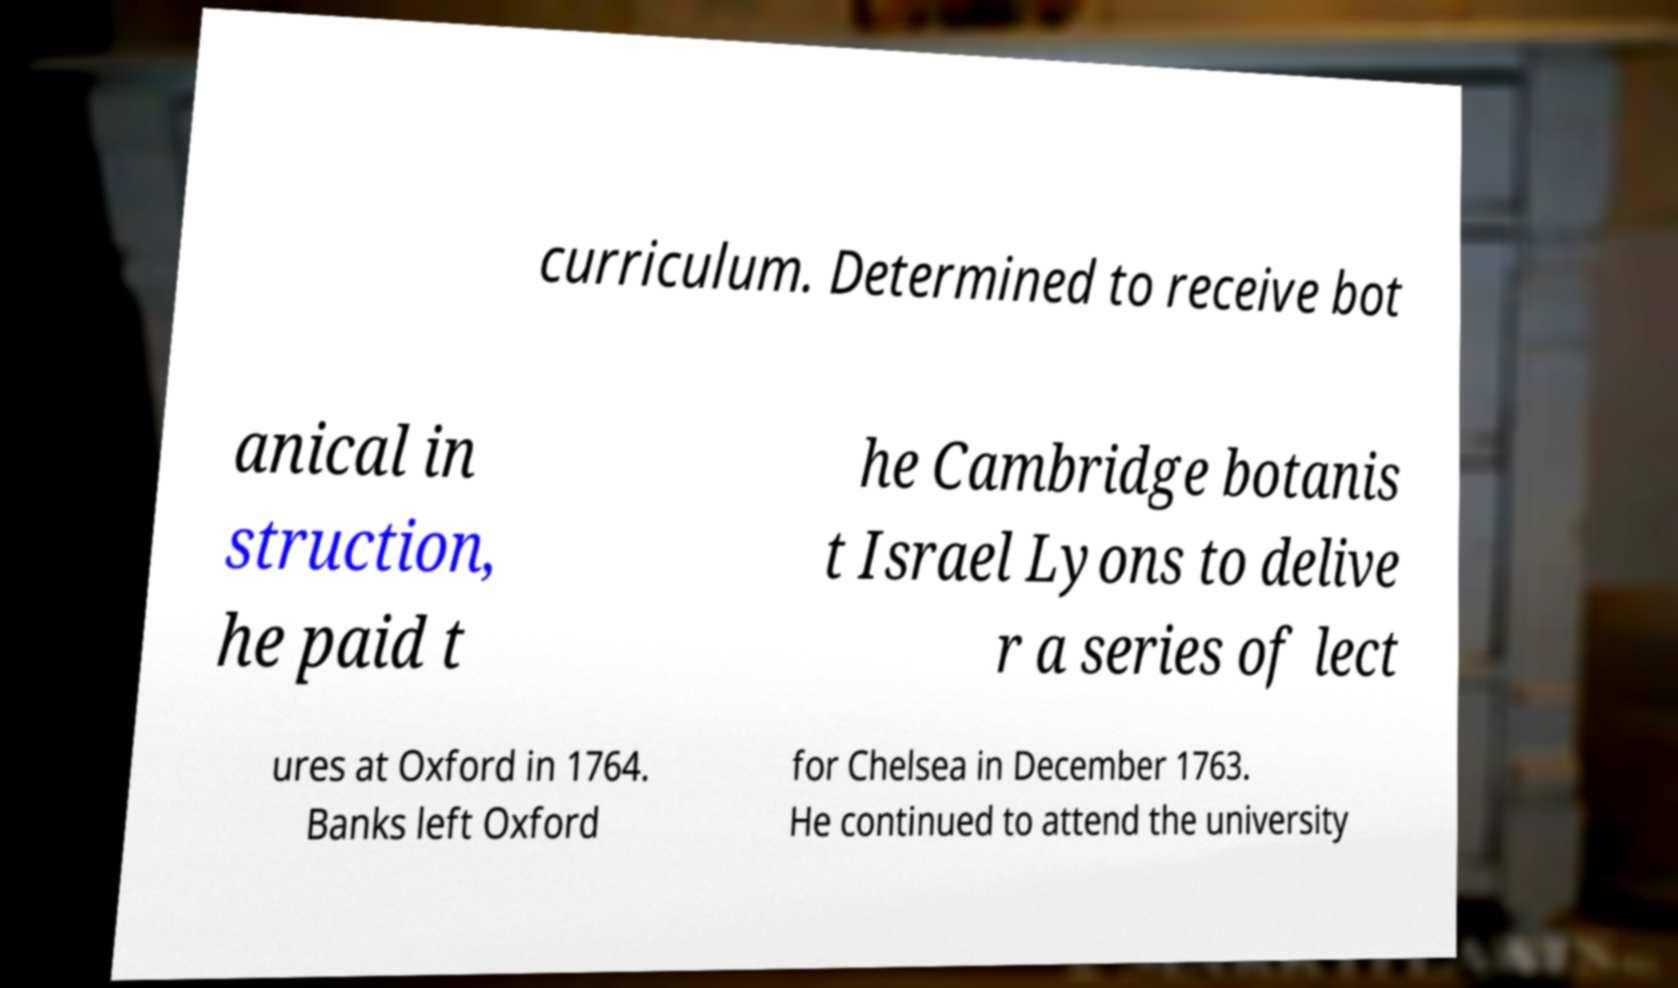Can you read and provide the text displayed in the image?This photo seems to have some interesting text. Can you extract and type it out for me? curriculum. Determined to receive bot anical in struction, he paid t he Cambridge botanis t Israel Lyons to delive r a series of lect ures at Oxford in 1764. Banks left Oxford for Chelsea in December 1763. He continued to attend the university 